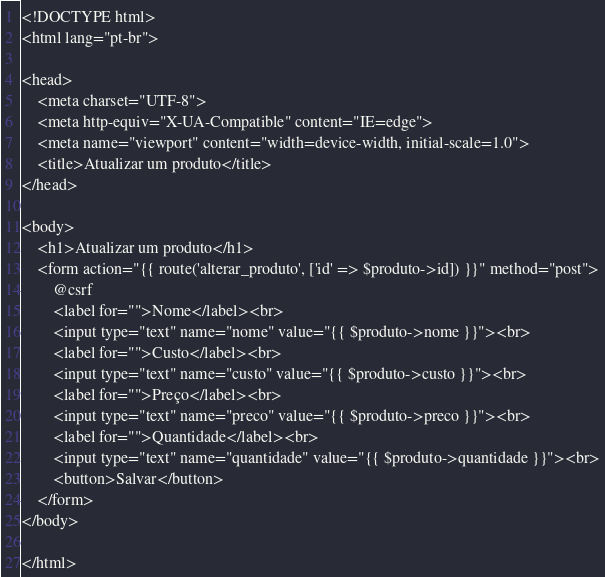Convert code to text. <code><loc_0><loc_0><loc_500><loc_500><_PHP_><!DOCTYPE html>
<html lang="pt-br">

<head>
    <meta charset="UTF-8">
    <meta http-equiv="X-UA-Compatible" content="IE=edge">
    <meta name="viewport" content="width=device-width, initial-scale=1.0">
    <title>Atualizar um produto</title>
</head>

<body>
    <h1>Atualizar um produto</h1>
    <form action="{{ route('alterar_produto', ['id' => $produto->id]) }}" method="post">
        @csrf
        <label for="">Nome</label><br>
        <input type="text" name="nome" value="{{ $produto->nome }}"><br>
        <label for="">Custo</label><br>
        <input type="text" name="custo" value="{{ $produto->custo }}"><br>
        <label for="">Preço</label><br>
        <input type="text" name="preco" value="{{ $produto->preco }}"><br>
        <label for="">Quantidade</label><br>
        <input type="text" name="quantidade" value="{{ $produto->quantidade }}"><br>
        <button>Salvar</button>
    </form>
</body>

</html></code> 